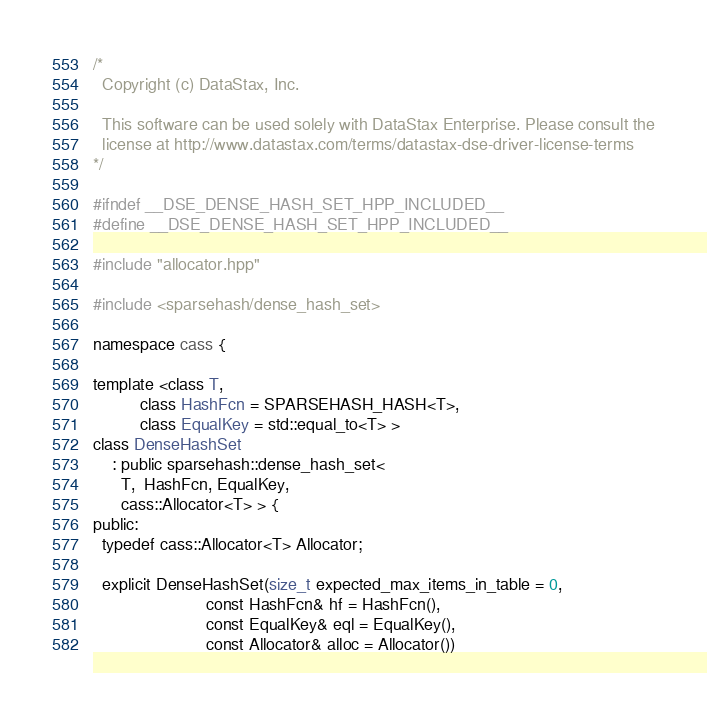<code> <loc_0><loc_0><loc_500><loc_500><_C++_>/*
  Copyright (c) DataStax, Inc.

  This software can be used solely with DataStax Enterprise. Please consult the
  license at http://www.datastax.com/terms/datastax-dse-driver-license-terms
*/

#ifndef __DSE_DENSE_HASH_SET_HPP_INCLUDED__
#define __DSE_DENSE_HASH_SET_HPP_INCLUDED__

#include "allocator.hpp"

#include <sparsehash/dense_hash_set>

namespace cass {

template <class T,
          class HashFcn = SPARSEHASH_HASH<T>,
          class EqualKey = std::equal_to<T> >
class DenseHashSet
    : public sparsehash::dense_hash_set<
      T,  HashFcn, EqualKey,
      cass::Allocator<T> > {
public:
  typedef cass::Allocator<T> Allocator;

  explicit DenseHashSet(size_t expected_max_items_in_table = 0,
                        const HashFcn& hf = HashFcn(),
                        const EqualKey& eql = EqualKey(),
                        const Allocator& alloc = Allocator())</code> 